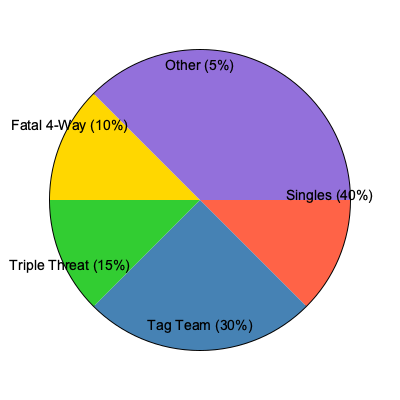Based on the pie chart representing AQA's career match types, what percentage of their matches have been in multi-person formats (excluding tag team matches)? To solve this question, we need to follow these steps:

1. Identify the multi-person match types in the pie chart:
   - Triple Threat: 15%
   - Fatal 4-Way: 10%
   - Other: 5% (We can assume these are also multi-person matches)

2. Add up the percentages of these match types:
   $15\% + 10\% + 5\% = 30\%$

3. Verify that we're not including tag team matches:
   - Tag Team matches are listed separately at 30%, and we're not including them in our calculation.

4. Double-check that singles matches (40%) are also excluded from our calculation.

Therefore, the total percentage of AQA's matches that have been in multi-person formats, excluding tag team matches, is 30%.
Answer: 30% 